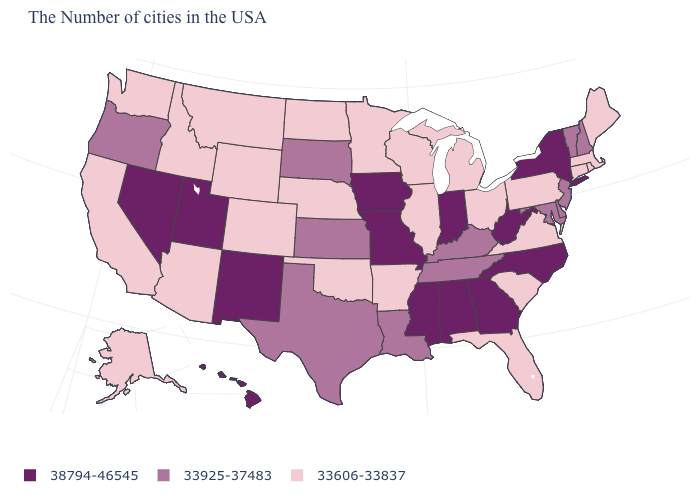Does Idaho have the lowest value in the USA?
Write a very short answer. Yes. What is the value of Wisconsin?
Short answer required. 33606-33837. What is the value of Wyoming?
Concise answer only. 33606-33837. What is the value of Wyoming?
Answer briefly. 33606-33837. Name the states that have a value in the range 33606-33837?
Give a very brief answer. Maine, Massachusetts, Rhode Island, Connecticut, Pennsylvania, Virginia, South Carolina, Ohio, Florida, Michigan, Wisconsin, Illinois, Arkansas, Minnesota, Nebraska, Oklahoma, North Dakota, Wyoming, Colorado, Montana, Arizona, Idaho, California, Washington, Alaska. Among the states that border New Mexico , does Arizona have the lowest value?
Answer briefly. Yes. Among the states that border Arizona , which have the highest value?
Give a very brief answer. New Mexico, Utah, Nevada. What is the value of Kentucky?
Give a very brief answer. 33925-37483. Which states have the lowest value in the West?
Concise answer only. Wyoming, Colorado, Montana, Arizona, Idaho, California, Washington, Alaska. What is the value of Idaho?
Concise answer only. 33606-33837. Is the legend a continuous bar?
Give a very brief answer. No. What is the value of West Virginia?
Give a very brief answer. 38794-46545. What is the value of Iowa?
Answer briefly. 38794-46545. Does Virginia have the lowest value in the South?
Give a very brief answer. Yes. What is the value of Georgia?
Keep it brief. 38794-46545. 